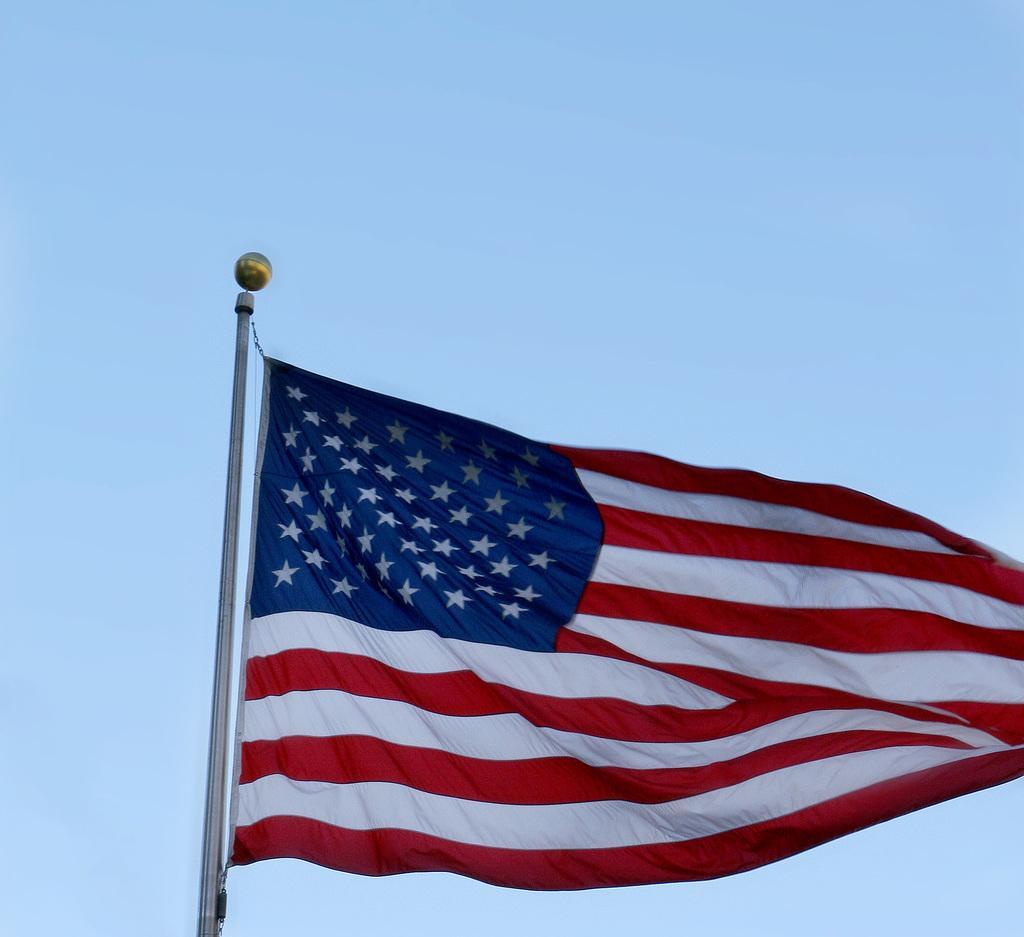Describe this image in one or two sentences. Here we can see a flag to a pole and there is an object on the pole. In the background we can see sky. 